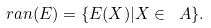<formula> <loc_0><loc_0><loc_500><loc_500>\ r a n ( E ) = \{ E ( X ) | X \in \ A \} .</formula> 